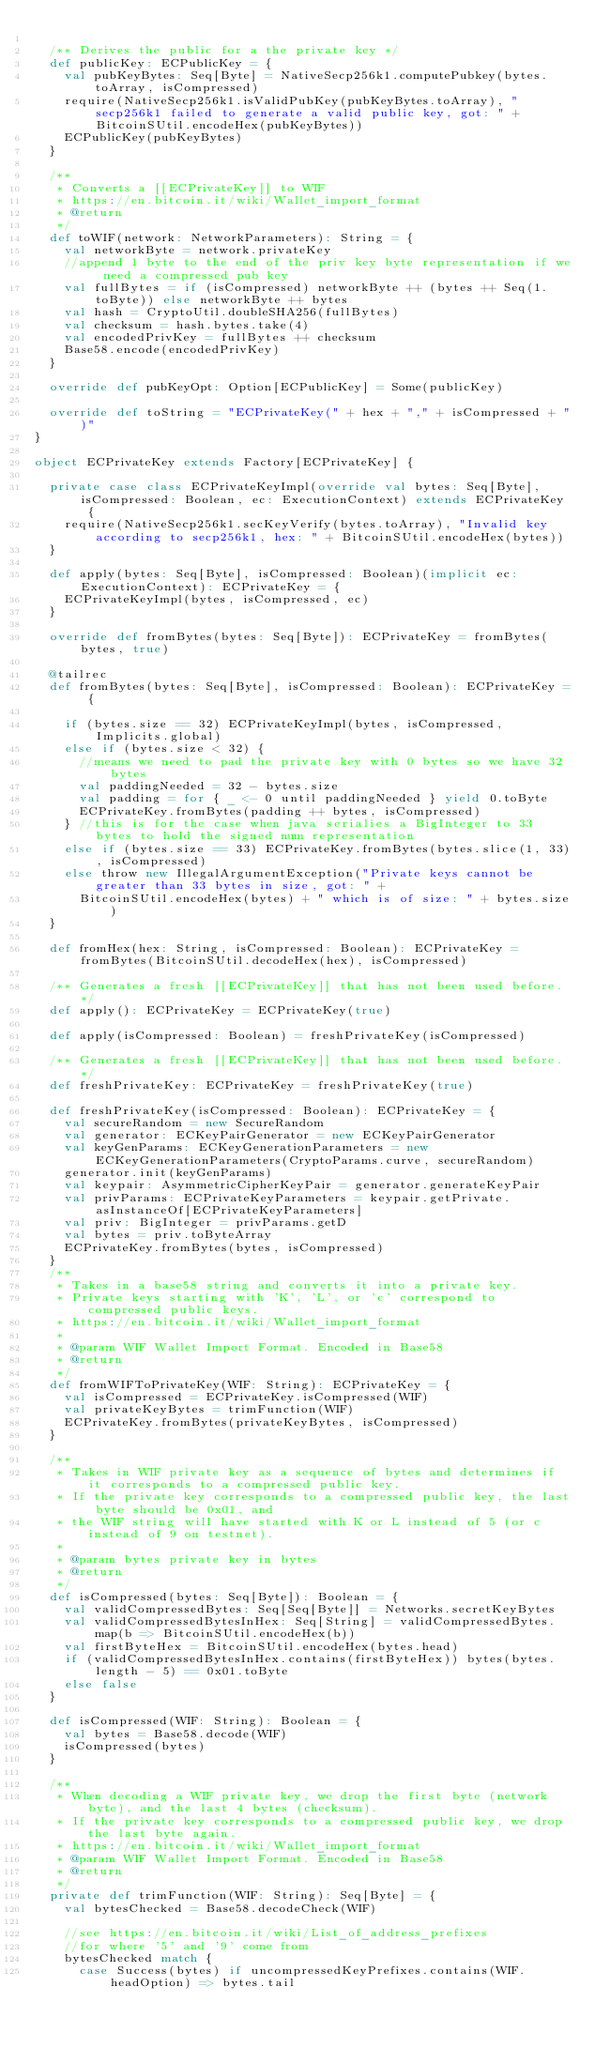Convert code to text. <code><loc_0><loc_0><loc_500><loc_500><_Scala_>
  /** Derives the public for a the private key */
  def publicKey: ECPublicKey = {
    val pubKeyBytes: Seq[Byte] = NativeSecp256k1.computePubkey(bytes.toArray, isCompressed)
    require(NativeSecp256k1.isValidPubKey(pubKeyBytes.toArray), "secp256k1 failed to generate a valid public key, got: " + BitcoinSUtil.encodeHex(pubKeyBytes))
    ECPublicKey(pubKeyBytes)
  }

  /**
   * Converts a [[ECPrivateKey]] to WIF
   * https://en.bitcoin.it/wiki/Wallet_import_format
   * @return
   */
  def toWIF(network: NetworkParameters): String = {
    val networkByte = network.privateKey
    //append 1 byte to the end of the priv key byte representation if we need a compressed pub key
    val fullBytes = if (isCompressed) networkByte ++ (bytes ++ Seq(1.toByte)) else networkByte ++ bytes
    val hash = CryptoUtil.doubleSHA256(fullBytes)
    val checksum = hash.bytes.take(4)
    val encodedPrivKey = fullBytes ++ checksum
    Base58.encode(encodedPrivKey)
  }

  override def pubKeyOpt: Option[ECPublicKey] = Some(publicKey)

  override def toString = "ECPrivateKey(" + hex + "," + isCompressed + ")"
}

object ECPrivateKey extends Factory[ECPrivateKey] {

  private case class ECPrivateKeyImpl(override val bytes: Seq[Byte], isCompressed: Boolean, ec: ExecutionContext) extends ECPrivateKey {
    require(NativeSecp256k1.secKeyVerify(bytes.toArray), "Invalid key according to secp256k1, hex: " + BitcoinSUtil.encodeHex(bytes))
  }

  def apply(bytes: Seq[Byte], isCompressed: Boolean)(implicit ec: ExecutionContext): ECPrivateKey = {
    ECPrivateKeyImpl(bytes, isCompressed, ec)
  }

  override def fromBytes(bytes: Seq[Byte]): ECPrivateKey = fromBytes(bytes, true)

  @tailrec
  def fromBytes(bytes: Seq[Byte], isCompressed: Boolean): ECPrivateKey = {

    if (bytes.size == 32) ECPrivateKeyImpl(bytes, isCompressed, Implicits.global)
    else if (bytes.size < 32) {
      //means we need to pad the private key with 0 bytes so we have 32 bytes
      val paddingNeeded = 32 - bytes.size
      val padding = for { _ <- 0 until paddingNeeded } yield 0.toByte
      ECPrivateKey.fromBytes(padding ++ bytes, isCompressed)
    } //this is for the case when java serialies a BigInteger to 33 bytes to hold the signed num representation
    else if (bytes.size == 33) ECPrivateKey.fromBytes(bytes.slice(1, 33), isCompressed)
    else throw new IllegalArgumentException("Private keys cannot be greater than 33 bytes in size, got: " +
      BitcoinSUtil.encodeHex(bytes) + " which is of size: " + bytes.size)
  }

  def fromHex(hex: String, isCompressed: Boolean): ECPrivateKey = fromBytes(BitcoinSUtil.decodeHex(hex), isCompressed)

  /** Generates a fresh [[ECPrivateKey]] that has not been used before. */
  def apply(): ECPrivateKey = ECPrivateKey(true)

  def apply(isCompressed: Boolean) = freshPrivateKey(isCompressed)

  /** Generates a fresh [[ECPrivateKey]] that has not been used before. */
  def freshPrivateKey: ECPrivateKey = freshPrivateKey(true)

  def freshPrivateKey(isCompressed: Boolean): ECPrivateKey = {
    val secureRandom = new SecureRandom
    val generator: ECKeyPairGenerator = new ECKeyPairGenerator
    val keyGenParams: ECKeyGenerationParameters = new ECKeyGenerationParameters(CryptoParams.curve, secureRandom)
    generator.init(keyGenParams)
    val keypair: AsymmetricCipherKeyPair = generator.generateKeyPair
    val privParams: ECPrivateKeyParameters = keypair.getPrivate.asInstanceOf[ECPrivateKeyParameters]
    val priv: BigInteger = privParams.getD
    val bytes = priv.toByteArray
    ECPrivateKey.fromBytes(bytes, isCompressed)
  }
  /**
   * Takes in a base58 string and converts it into a private key.
   * Private keys starting with 'K', 'L', or 'c' correspond to compressed public keys.
   * https://en.bitcoin.it/wiki/Wallet_import_format
   *
   * @param WIF Wallet Import Format. Encoded in Base58
   * @return
   */
  def fromWIFToPrivateKey(WIF: String): ECPrivateKey = {
    val isCompressed = ECPrivateKey.isCompressed(WIF)
    val privateKeyBytes = trimFunction(WIF)
    ECPrivateKey.fromBytes(privateKeyBytes, isCompressed)
  }

  /**
   * Takes in WIF private key as a sequence of bytes and determines if it corresponds to a compressed public key.
   * If the private key corresponds to a compressed public key, the last byte should be 0x01, and
   * the WIF string will have started with K or L instead of 5 (or c instead of 9 on testnet).
   *
   * @param bytes private key in bytes
   * @return
   */
  def isCompressed(bytes: Seq[Byte]): Boolean = {
    val validCompressedBytes: Seq[Seq[Byte]] = Networks.secretKeyBytes
    val validCompressedBytesInHex: Seq[String] = validCompressedBytes.map(b => BitcoinSUtil.encodeHex(b))
    val firstByteHex = BitcoinSUtil.encodeHex(bytes.head)
    if (validCompressedBytesInHex.contains(firstByteHex)) bytes(bytes.length - 5) == 0x01.toByte
    else false
  }

  def isCompressed(WIF: String): Boolean = {
    val bytes = Base58.decode(WIF)
    isCompressed(bytes)
  }

  /**
   * When decoding a WIF private key, we drop the first byte (network byte), and the last 4 bytes (checksum).
   * If the private key corresponds to a compressed public key, we drop the last byte again.
   * https://en.bitcoin.it/wiki/Wallet_import_format
   * @param WIF Wallet Import Format. Encoded in Base58
   * @return
   */
  private def trimFunction(WIF: String): Seq[Byte] = {
    val bytesChecked = Base58.decodeCheck(WIF)

    //see https://en.bitcoin.it/wiki/List_of_address_prefixes
    //for where '5' and '9' come from
    bytesChecked match {
      case Success(bytes) if uncompressedKeyPrefixes.contains(WIF.headOption) => bytes.tail</code> 